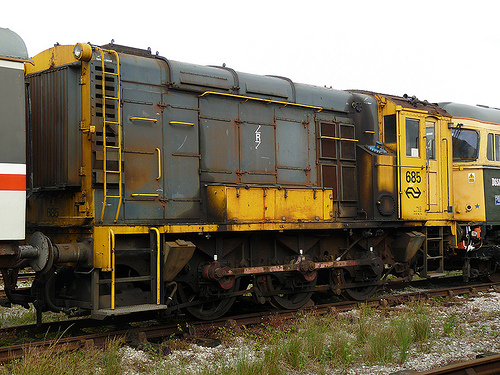Imagine the train car could talk. What would it say about its journey? If the train car could talk, it might share stories of the countless miles it has traveled and the cargo it has carried. It would recall vivid memories of bustling stations, the rhythmic clatter of wheels on tracks, and the changing landscapes it has traversed, from urban sprawls to serene countrysides. It could speak of the people it has seen, the maintenance it has undergone, and its gradual transformation over time, bearing the marks of its long and storied service. 